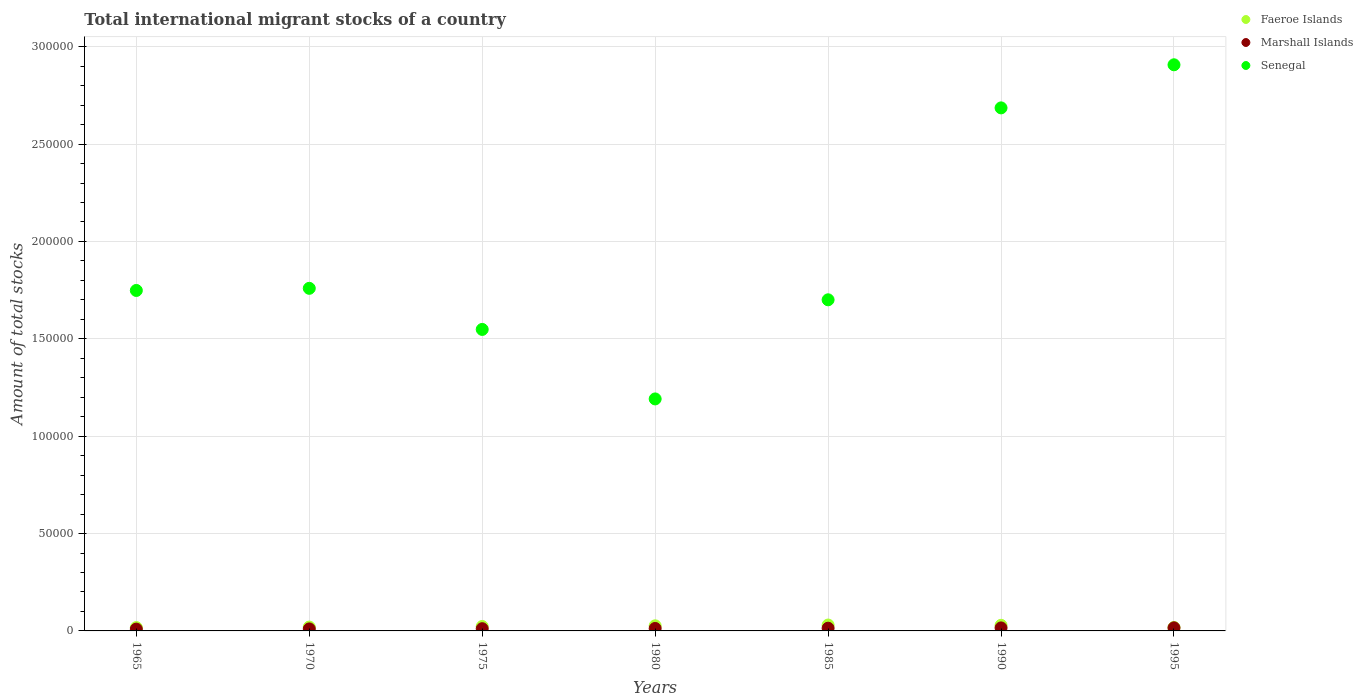How many different coloured dotlines are there?
Ensure brevity in your answer.  3. What is the amount of total stocks in in Senegal in 1980?
Your answer should be compact. 1.19e+05. Across all years, what is the maximum amount of total stocks in in Marshall Islands?
Your answer should be compact. 1586. Across all years, what is the minimum amount of total stocks in in Senegal?
Provide a succinct answer. 1.19e+05. In which year was the amount of total stocks in in Senegal minimum?
Your answer should be compact. 1980. What is the total amount of total stocks in in Faeroe Islands in the graph?
Your answer should be very brief. 1.63e+04. What is the difference between the amount of total stocks in in Marshall Islands in 1965 and that in 1985?
Offer a terse response. -463. What is the difference between the amount of total stocks in in Senegal in 1975 and the amount of total stocks in in Faeroe Islands in 1970?
Make the answer very short. 1.53e+05. What is the average amount of total stocks in in Marshall Islands per year?
Your response must be concise. 1273.14. In the year 1990, what is the difference between the amount of total stocks in in Faeroe Islands and amount of total stocks in in Senegal?
Ensure brevity in your answer.  -2.66e+05. In how many years, is the amount of total stocks in in Faeroe Islands greater than 130000?
Your response must be concise. 0. What is the ratio of the amount of total stocks in in Faeroe Islands in 1965 to that in 1970?
Ensure brevity in your answer.  0.87. What is the difference between the highest and the second highest amount of total stocks in in Senegal?
Provide a succinct answer. 2.21e+04. What is the difference between the highest and the lowest amount of total stocks in in Senegal?
Offer a very short reply. 1.72e+05. In how many years, is the amount of total stocks in in Marshall Islands greater than the average amount of total stocks in in Marshall Islands taken over all years?
Keep it short and to the point. 3. Is the sum of the amount of total stocks in in Senegal in 1990 and 1995 greater than the maximum amount of total stocks in in Faeroe Islands across all years?
Make the answer very short. Yes. Does the amount of total stocks in in Faeroe Islands monotonically increase over the years?
Give a very brief answer. No. Is the amount of total stocks in in Marshall Islands strictly less than the amount of total stocks in in Faeroe Islands over the years?
Provide a succinct answer. Yes. How many dotlines are there?
Give a very brief answer. 3. How many years are there in the graph?
Your answer should be very brief. 7. What is the difference between two consecutive major ticks on the Y-axis?
Provide a short and direct response. 5.00e+04. Does the graph contain any zero values?
Give a very brief answer. No. How many legend labels are there?
Give a very brief answer. 3. How are the legend labels stacked?
Offer a terse response. Vertical. What is the title of the graph?
Your answer should be compact. Total international migrant stocks of a country. What is the label or title of the Y-axis?
Ensure brevity in your answer.  Amount of total stocks. What is the Amount of total stocks of Faeroe Islands in 1965?
Make the answer very short. 1716. What is the Amount of total stocks of Marshall Islands in 1965?
Keep it short and to the point. 936. What is the Amount of total stocks of Senegal in 1965?
Provide a succinct answer. 1.75e+05. What is the Amount of total stocks in Faeroe Islands in 1970?
Your response must be concise. 1978. What is the Amount of total stocks in Marshall Islands in 1970?
Make the answer very short. 1035. What is the Amount of total stocks in Senegal in 1970?
Your answer should be very brief. 1.76e+05. What is the Amount of total stocks in Faeroe Islands in 1975?
Ensure brevity in your answer.  2280. What is the Amount of total stocks of Marshall Islands in 1975?
Your answer should be very brief. 1144. What is the Amount of total stocks in Senegal in 1975?
Keep it short and to the point. 1.55e+05. What is the Amount of total stocks in Faeroe Islands in 1980?
Provide a short and direct response. 2628. What is the Amount of total stocks in Marshall Islands in 1980?
Ensure brevity in your answer.  1265. What is the Amount of total stocks in Senegal in 1980?
Ensure brevity in your answer.  1.19e+05. What is the Amount of total stocks in Faeroe Islands in 1985?
Your answer should be compact. 3029. What is the Amount of total stocks in Marshall Islands in 1985?
Your answer should be very brief. 1399. What is the Amount of total stocks of Senegal in 1985?
Keep it short and to the point. 1.70e+05. What is the Amount of total stocks of Faeroe Islands in 1990?
Give a very brief answer. 2881. What is the Amount of total stocks in Marshall Islands in 1990?
Provide a short and direct response. 1547. What is the Amount of total stocks in Senegal in 1990?
Your answer should be compact. 2.69e+05. What is the Amount of total stocks in Faeroe Islands in 1995?
Provide a succinct answer. 1747. What is the Amount of total stocks of Marshall Islands in 1995?
Offer a terse response. 1586. What is the Amount of total stocks in Senegal in 1995?
Make the answer very short. 2.91e+05. Across all years, what is the maximum Amount of total stocks of Faeroe Islands?
Give a very brief answer. 3029. Across all years, what is the maximum Amount of total stocks in Marshall Islands?
Make the answer very short. 1586. Across all years, what is the maximum Amount of total stocks in Senegal?
Make the answer very short. 2.91e+05. Across all years, what is the minimum Amount of total stocks of Faeroe Islands?
Ensure brevity in your answer.  1716. Across all years, what is the minimum Amount of total stocks of Marshall Islands?
Your answer should be very brief. 936. Across all years, what is the minimum Amount of total stocks in Senegal?
Keep it short and to the point. 1.19e+05. What is the total Amount of total stocks of Faeroe Islands in the graph?
Ensure brevity in your answer.  1.63e+04. What is the total Amount of total stocks in Marshall Islands in the graph?
Provide a short and direct response. 8912. What is the total Amount of total stocks of Senegal in the graph?
Make the answer very short. 1.35e+06. What is the difference between the Amount of total stocks in Faeroe Islands in 1965 and that in 1970?
Your answer should be compact. -262. What is the difference between the Amount of total stocks of Marshall Islands in 1965 and that in 1970?
Ensure brevity in your answer.  -99. What is the difference between the Amount of total stocks in Senegal in 1965 and that in 1970?
Offer a terse response. -1093. What is the difference between the Amount of total stocks in Faeroe Islands in 1965 and that in 1975?
Offer a terse response. -564. What is the difference between the Amount of total stocks of Marshall Islands in 1965 and that in 1975?
Keep it short and to the point. -208. What is the difference between the Amount of total stocks of Senegal in 1965 and that in 1975?
Make the answer very short. 2.00e+04. What is the difference between the Amount of total stocks of Faeroe Islands in 1965 and that in 1980?
Offer a terse response. -912. What is the difference between the Amount of total stocks in Marshall Islands in 1965 and that in 1980?
Provide a succinct answer. -329. What is the difference between the Amount of total stocks in Senegal in 1965 and that in 1980?
Offer a very short reply. 5.57e+04. What is the difference between the Amount of total stocks in Faeroe Islands in 1965 and that in 1985?
Offer a very short reply. -1313. What is the difference between the Amount of total stocks of Marshall Islands in 1965 and that in 1985?
Offer a very short reply. -463. What is the difference between the Amount of total stocks of Senegal in 1965 and that in 1985?
Make the answer very short. 4798. What is the difference between the Amount of total stocks of Faeroe Islands in 1965 and that in 1990?
Make the answer very short. -1165. What is the difference between the Amount of total stocks in Marshall Islands in 1965 and that in 1990?
Make the answer very short. -611. What is the difference between the Amount of total stocks of Senegal in 1965 and that in 1990?
Your answer should be very brief. -9.38e+04. What is the difference between the Amount of total stocks in Faeroe Islands in 1965 and that in 1995?
Make the answer very short. -31. What is the difference between the Amount of total stocks in Marshall Islands in 1965 and that in 1995?
Offer a terse response. -650. What is the difference between the Amount of total stocks of Senegal in 1965 and that in 1995?
Your response must be concise. -1.16e+05. What is the difference between the Amount of total stocks of Faeroe Islands in 1970 and that in 1975?
Your answer should be very brief. -302. What is the difference between the Amount of total stocks of Marshall Islands in 1970 and that in 1975?
Your response must be concise. -109. What is the difference between the Amount of total stocks in Senegal in 1970 and that in 1975?
Give a very brief answer. 2.11e+04. What is the difference between the Amount of total stocks of Faeroe Islands in 1970 and that in 1980?
Your response must be concise. -650. What is the difference between the Amount of total stocks in Marshall Islands in 1970 and that in 1980?
Make the answer very short. -230. What is the difference between the Amount of total stocks of Senegal in 1970 and that in 1980?
Your response must be concise. 5.68e+04. What is the difference between the Amount of total stocks in Faeroe Islands in 1970 and that in 1985?
Your answer should be very brief. -1051. What is the difference between the Amount of total stocks in Marshall Islands in 1970 and that in 1985?
Offer a very short reply. -364. What is the difference between the Amount of total stocks in Senegal in 1970 and that in 1985?
Ensure brevity in your answer.  5891. What is the difference between the Amount of total stocks of Faeroe Islands in 1970 and that in 1990?
Ensure brevity in your answer.  -903. What is the difference between the Amount of total stocks of Marshall Islands in 1970 and that in 1990?
Your response must be concise. -512. What is the difference between the Amount of total stocks in Senegal in 1970 and that in 1990?
Your response must be concise. -9.27e+04. What is the difference between the Amount of total stocks in Faeroe Islands in 1970 and that in 1995?
Offer a terse response. 231. What is the difference between the Amount of total stocks of Marshall Islands in 1970 and that in 1995?
Give a very brief answer. -551. What is the difference between the Amount of total stocks in Senegal in 1970 and that in 1995?
Offer a terse response. -1.15e+05. What is the difference between the Amount of total stocks of Faeroe Islands in 1975 and that in 1980?
Ensure brevity in your answer.  -348. What is the difference between the Amount of total stocks of Marshall Islands in 1975 and that in 1980?
Provide a succinct answer. -121. What is the difference between the Amount of total stocks in Senegal in 1975 and that in 1980?
Provide a short and direct response. 3.57e+04. What is the difference between the Amount of total stocks in Faeroe Islands in 1975 and that in 1985?
Your answer should be very brief. -749. What is the difference between the Amount of total stocks of Marshall Islands in 1975 and that in 1985?
Your response must be concise. -255. What is the difference between the Amount of total stocks in Senegal in 1975 and that in 1985?
Provide a succinct answer. -1.52e+04. What is the difference between the Amount of total stocks in Faeroe Islands in 1975 and that in 1990?
Keep it short and to the point. -601. What is the difference between the Amount of total stocks of Marshall Islands in 1975 and that in 1990?
Ensure brevity in your answer.  -403. What is the difference between the Amount of total stocks of Senegal in 1975 and that in 1990?
Keep it short and to the point. -1.14e+05. What is the difference between the Amount of total stocks in Faeroe Islands in 1975 and that in 1995?
Provide a short and direct response. 533. What is the difference between the Amount of total stocks in Marshall Islands in 1975 and that in 1995?
Your answer should be compact. -442. What is the difference between the Amount of total stocks in Senegal in 1975 and that in 1995?
Your response must be concise. -1.36e+05. What is the difference between the Amount of total stocks of Faeroe Islands in 1980 and that in 1985?
Keep it short and to the point. -401. What is the difference between the Amount of total stocks in Marshall Islands in 1980 and that in 1985?
Make the answer very short. -134. What is the difference between the Amount of total stocks in Senegal in 1980 and that in 1985?
Your response must be concise. -5.09e+04. What is the difference between the Amount of total stocks of Faeroe Islands in 1980 and that in 1990?
Make the answer very short. -253. What is the difference between the Amount of total stocks of Marshall Islands in 1980 and that in 1990?
Offer a terse response. -282. What is the difference between the Amount of total stocks in Senegal in 1980 and that in 1990?
Ensure brevity in your answer.  -1.49e+05. What is the difference between the Amount of total stocks in Faeroe Islands in 1980 and that in 1995?
Give a very brief answer. 881. What is the difference between the Amount of total stocks in Marshall Islands in 1980 and that in 1995?
Keep it short and to the point. -321. What is the difference between the Amount of total stocks of Senegal in 1980 and that in 1995?
Give a very brief answer. -1.72e+05. What is the difference between the Amount of total stocks of Faeroe Islands in 1985 and that in 1990?
Provide a short and direct response. 148. What is the difference between the Amount of total stocks in Marshall Islands in 1985 and that in 1990?
Make the answer very short. -148. What is the difference between the Amount of total stocks of Senegal in 1985 and that in 1990?
Give a very brief answer. -9.85e+04. What is the difference between the Amount of total stocks in Faeroe Islands in 1985 and that in 1995?
Provide a succinct answer. 1282. What is the difference between the Amount of total stocks in Marshall Islands in 1985 and that in 1995?
Provide a short and direct response. -187. What is the difference between the Amount of total stocks of Senegal in 1985 and that in 1995?
Provide a short and direct response. -1.21e+05. What is the difference between the Amount of total stocks in Faeroe Islands in 1990 and that in 1995?
Provide a short and direct response. 1134. What is the difference between the Amount of total stocks of Marshall Islands in 1990 and that in 1995?
Provide a succinct answer. -39. What is the difference between the Amount of total stocks of Senegal in 1990 and that in 1995?
Make the answer very short. -2.21e+04. What is the difference between the Amount of total stocks in Faeroe Islands in 1965 and the Amount of total stocks in Marshall Islands in 1970?
Offer a very short reply. 681. What is the difference between the Amount of total stocks of Faeroe Islands in 1965 and the Amount of total stocks of Senegal in 1970?
Offer a very short reply. -1.74e+05. What is the difference between the Amount of total stocks in Marshall Islands in 1965 and the Amount of total stocks in Senegal in 1970?
Ensure brevity in your answer.  -1.75e+05. What is the difference between the Amount of total stocks of Faeroe Islands in 1965 and the Amount of total stocks of Marshall Islands in 1975?
Provide a succinct answer. 572. What is the difference between the Amount of total stocks in Faeroe Islands in 1965 and the Amount of total stocks in Senegal in 1975?
Provide a succinct answer. -1.53e+05. What is the difference between the Amount of total stocks in Marshall Islands in 1965 and the Amount of total stocks in Senegal in 1975?
Provide a succinct answer. -1.54e+05. What is the difference between the Amount of total stocks in Faeroe Islands in 1965 and the Amount of total stocks in Marshall Islands in 1980?
Make the answer very short. 451. What is the difference between the Amount of total stocks of Faeroe Islands in 1965 and the Amount of total stocks of Senegal in 1980?
Your response must be concise. -1.17e+05. What is the difference between the Amount of total stocks of Marshall Islands in 1965 and the Amount of total stocks of Senegal in 1980?
Provide a short and direct response. -1.18e+05. What is the difference between the Amount of total stocks of Faeroe Islands in 1965 and the Amount of total stocks of Marshall Islands in 1985?
Provide a succinct answer. 317. What is the difference between the Amount of total stocks of Faeroe Islands in 1965 and the Amount of total stocks of Senegal in 1985?
Provide a succinct answer. -1.68e+05. What is the difference between the Amount of total stocks of Marshall Islands in 1965 and the Amount of total stocks of Senegal in 1985?
Offer a very short reply. -1.69e+05. What is the difference between the Amount of total stocks of Faeroe Islands in 1965 and the Amount of total stocks of Marshall Islands in 1990?
Keep it short and to the point. 169. What is the difference between the Amount of total stocks of Faeroe Islands in 1965 and the Amount of total stocks of Senegal in 1990?
Keep it short and to the point. -2.67e+05. What is the difference between the Amount of total stocks in Marshall Islands in 1965 and the Amount of total stocks in Senegal in 1990?
Offer a very short reply. -2.68e+05. What is the difference between the Amount of total stocks of Faeroe Islands in 1965 and the Amount of total stocks of Marshall Islands in 1995?
Keep it short and to the point. 130. What is the difference between the Amount of total stocks in Faeroe Islands in 1965 and the Amount of total stocks in Senegal in 1995?
Ensure brevity in your answer.  -2.89e+05. What is the difference between the Amount of total stocks in Marshall Islands in 1965 and the Amount of total stocks in Senegal in 1995?
Ensure brevity in your answer.  -2.90e+05. What is the difference between the Amount of total stocks in Faeroe Islands in 1970 and the Amount of total stocks in Marshall Islands in 1975?
Offer a very short reply. 834. What is the difference between the Amount of total stocks in Faeroe Islands in 1970 and the Amount of total stocks in Senegal in 1975?
Offer a terse response. -1.53e+05. What is the difference between the Amount of total stocks in Marshall Islands in 1970 and the Amount of total stocks in Senegal in 1975?
Provide a succinct answer. -1.54e+05. What is the difference between the Amount of total stocks in Faeroe Islands in 1970 and the Amount of total stocks in Marshall Islands in 1980?
Your response must be concise. 713. What is the difference between the Amount of total stocks of Faeroe Islands in 1970 and the Amount of total stocks of Senegal in 1980?
Offer a terse response. -1.17e+05. What is the difference between the Amount of total stocks in Marshall Islands in 1970 and the Amount of total stocks in Senegal in 1980?
Your answer should be very brief. -1.18e+05. What is the difference between the Amount of total stocks of Faeroe Islands in 1970 and the Amount of total stocks of Marshall Islands in 1985?
Ensure brevity in your answer.  579. What is the difference between the Amount of total stocks of Faeroe Islands in 1970 and the Amount of total stocks of Senegal in 1985?
Keep it short and to the point. -1.68e+05. What is the difference between the Amount of total stocks in Marshall Islands in 1970 and the Amount of total stocks in Senegal in 1985?
Offer a terse response. -1.69e+05. What is the difference between the Amount of total stocks of Faeroe Islands in 1970 and the Amount of total stocks of Marshall Islands in 1990?
Make the answer very short. 431. What is the difference between the Amount of total stocks of Faeroe Islands in 1970 and the Amount of total stocks of Senegal in 1990?
Give a very brief answer. -2.67e+05. What is the difference between the Amount of total stocks in Marshall Islands in 1970 and the Amount of total stocks in Senegal in 1990?
Your answer should be compact. -2.68e+05. What is the difference between the Amount of total stocks of Faeroe Islands in 1970 and the Amount of total stocks of Marshall Islands in 1995?
Your answer should be compact. 392. What is the difference between the Amount of total stocks of Faeroe Islands in 1970 and the Amount of total stocks of Senegal in 1995?
Give a very brief answer. -2.89e+05. What is the difference between the Amount of total stocks of Marshall Islands in 1970 and the Amount of total stocks of Senegal in 1995?
Keep it short and to the point. -2.90e+05. What is the difference between the Amount of total stocks of Faeroe Islands in 1975 and the Amount of total stocks of Marshall Islands in 1980?
Ensure brevity in your answer.  1015. What is the difference between the Amount of total stocks in Faeroe Islands in 1975 and the Amount of total stocks in Senegal in 1980?
Ensure brevity in your answer.  -1.17e+05. What is the difference between the Amount of total stocks in Marshall Islands in 1975 and the Amount of total stocks in Senegal in 1980?
Keep it short and to the point. -1.18e+05. What is the difference between the Amount of total stocks in Faeroe Islands in 1975 and the Amount of total stocks in Marshall Islands in 1985?
Offer a terse response. 881. What is the difference between the Amount of total stocks in Faeroe Islands in 1975 and the Amount of total stocks in Senegal in 1985?
Provide a short and direct response. -1.68e+05. What is the difference between the Amount of total stocks in Marshall Islands in 1975 and the Amount of total stocks in Senegal in 1985?
Keep it short and to the point. -1.69e+05. What is the difference between the Amount of total stocks in Faeroe Islands in 1975 and the Amount of total stocks in Marshall Islands in 1990?
Provide a short and direct response. 733. What is the difference between the Amount of total stocks in Faeroe Islands in 1975 and the Amount of total stocks in Senegal in 1990?
Provide a succinct answer. -2.66e+05. What is the difference between the Amount of total stocks in Marshall Islands in 1975 and the Amount of total stocks in Senegal in 1990?
Your answer should be compact. -2.67e+05. What is the difference between the Amount of total stocks of Faeroe Islands in 1975 and the Amount of total stocks of Marshall Islands in 1995?
Keep it short and to the point. 694. What is the difference between the Amount of total stocks of Faeroe Islands in 1975 and the Amount of total stocks of Senegal in 1995?
Give a very brief answer. -2.88e+05. What is the difference between the Amount of total stocks in Marshall Islands in 1975 and the Amount of total stocks in Senegal in 1995?
Your answer should be compact. -2.90e+05. What is the difference between the Amount of total stocks in Faeroe Islands in 1980 and the Amount of total stocks in Marshall Islands in 1985?
Give a very brief answer. 1229. What is the difference between the Amount of total stocks of Faeroe Islands in 1980 and the Amount of total stocks of Senegal in 1985?
Offer a very short reply. -1.67e+05. What is the difference between the Amount of total stocks in Marshall Islands in 1980 and the Amount of total stocks in Senegal in 1985?
Provide a succinct answer. -1.69e+05. What is the difference between the Amount of total stocks of Faeroe Islands in 1980 and the Amount of total stocks of Marshall Islands in 1990?
Provide a succinct answer. 1081. What is the difference between the Amount of total stocks of Faeroe Islands in 1980 and the Amount of total stocks of Senegal in 1990?
Provide a succinct answer. -2.66e+05. What is the difference between the Amount of total stocks of Marshall Islands in 1980 and the Amount of total stocks of Senegal in 1990?
Your answer should be very brief. -2.67e+05. What is the difference between the Amount of total stocks in Faeroe Islands in 1980 and the Amount of total stocks in Marshall Islands in 1995?
Your answer should be very brief. 1042. What is the difference between the Amount of total stocks in Faeroe Islands in 1980 and the Amount of total stocks in Senegal in 1995?
Offer a terse response. -2.88e+05. What is the difference between the Amount of total stocks in Marshall Islands in 1980 and the Amount of total stocks in Senegal in 1995?
Give a very brief answer. -2.89e+05. What is the difference between the Amount of total stocks of Faeroe Islands in 1985 and the Amount of total stocks of Marshall Islands in 1990?
Your response must be concise. 1482. What is the difference between the Amount of total stocks of Faeroe Islands in 1985 and the Amount of total stocks of Senegal in 1990?
Offer a terse response. -2.66e+05. What is the difference between the Amount of total stocks of Marshall Islands in 1985 and the Amount of total stocks of Senegal in 1990?
Your response must be concise. -2.67e+05. What is the difference between the Amount of total stocks in Faeroe Islands in 1985 and the Amount of total stocks in Marshall Islands in 1995?
Provide a short and direct response. 1443. What is the difference between the Amount of total stocks in Faeroe Islands in 1985 and the Amount of total stocks in Senegal in 1995?
Give a very brief answer. -2.88e+05. What is the difference between the Amount of total stocks in Marshall Islands in 1985 and the Amount of total stocks in Senegal in 1995?
Offer a very short reply. -2.89e+05. What is the difference between the Amount of total stocks in Faeroe Islands in 1990 and the Amount of total stocks in Marshall Islands in 1995?
Your response must be concise. 1295. What is the difference between the Amount of total stocks in Faeroe Islands in 1990 and the Amount of total stocks in Senegal in 1995?
Make the answer very short. -2.88e+05. What is the difference between the Amount of total stocks in Marshall Islands in 1990 and the Amount of total stocks in Senegal in 1995?
Give a very brief answer. -2.89e+05. What is the average Amount of total stocks in Faeroe Islands per year?
Keep it short and to the point. 2322.71. What is the average Amount of total stocks in Marshall Islands per year?
Keep it short and to the point. 1273.14. What is the average Amount of total stocks in Senegal per year?
Offer a terse response. 1.93e+05. In the year 1965, what is the difference between the Amount of total stocks of Faeroe Islands and Amount of total stocks of Marshall Islands?
Your answer should be compact. 780. In the year 1965, what is the difference between the Amount of total stocks in Faeroe Islands and Amount of total stocks in Senegal?
Provide a short and direct response. -1.73e+05. In the year 1965, what is the difference between the Amount of total stocks of Marshall Islands and Amount of total stocks of Senegal?
Offer a terse response. -1.74e+05. In the year 1970, what is the difference between the Amount of total stocks of Faeroe Islands and Amount of total stocks of Marshall Islands?
Your answer should be compact. 943. In the year 1970, what is the difference between the Amount of total stocks in Faeroe Islands and Amount of total stocks in Senegal?
Give a very brief answer. -1.74e+05. In the year 1970, what is the difference between the Amount of total stocks in Marshall Islands and Amount of total stocks in Senegal?
Your answer should be compact. -1.75e+05. In the year 1975, what is the difference between the Amount of total stocks of Faeroe Islands and Amount of total stocks of Marshall Islands?
Provide a succinct answer. 1136. In the year 1975, what is the difference between the Amount of total stocks of Faeroe Islands and Amount of total stocks of Senegal?
Offer a very short reply. -1.53e+05. In the year 1975, what is the difference between the Amount of total stocks of Marshall Islands and Amount of total stocks of Senegal?
Offer a very short reply. -1.54e+05. In the year 1980, what is the difference between the Amount of total stocks of Faeroe Islands and Amount of total stocks of Marshall Islands?
Your answer should be very brief. 1363. In the year 1980, what is the difference between the Amount of total stocks of Faeroe Islands and Amount of total stocks of Senegal?
Your answer should be very brief. -1.16e+05. In the year 1980, what is the difference between the Amount of total stocks in Marshall Islands and Amount of total stocks in Senegal?
Make the answer very short. -1.18e+05. In the year 1985, what is the difference between the Amount of total stocks of Faeroe Islands and Amount of total stocks of Marshall Islands?
Your answer should be very brief. 1630. In the year 1985, what is the difference between the Amount of total stocks in Faeroe Islands and Amount of total stocks in Senegal?
Your response must be concise. -1.67e+05. In the year 1985, what is the difference between the Amount of total stocks in Marshall Islands and Amount of total stocks in Senegal?
Offer a terse response. -1.69e+05. In the year 1990, what is the difference between the Amount of total stocks of Faeroe Islands and Amount of total stocks of Marshall Islands?
Your response must be concise. 1334. In the year 1990, what is the difference between the Amount of total stocks in Faeroe Islands and Amount of total stocks in Senegal?
Provide a succinct answer. -2.66e+05. In the year 1990, what is the difference between the Amount of total stocks in Marshall Islands and Amount of total stocks in Senegal?
Your answer should be very brief. -2.67e+05. In the year 1995, what is the difference between the Amount of total stocks in Faeroe Islands and Amount of total stocks in Marshall Islands?
Make the answer very short. 161. In the year 1995, what is the difference between the Amount of total stocks in Faeroe Islands and Amount of total stocks in Senegal?
Keep it short and to the point. -2.89e+05. In the year 1995, what is the difference between the Amount of total stocks of Marshall Islands and Amount of total stocks of Senegal?
Give a very brief answer. -2.89e+05. What is the ratio of the Amount of total stocks in Faeroe Islands in 1965 to that in 1970?
Give a very brief answer. 0.87. What is the ratio of the Amount of total stocks in Marshall Islands in 1965 to that in 1970?
Give a very brief answer. 0.9. What is the ratio of the Amount of total stocks in Faeroe Islands in 1965 to that in 1975?
Offer a very short reply. 0.75. What is the ratio of the Amount of total stocks of Marshall Islands in 1965 to that in 1975?
Offer a terse response. 0.82. What is the ratio of the Amount of total stocks of Senegal in 1965 to that in 1975?
Offer a very short reply. 1.13. What is the ratio of the Amount of total stocks in Faeroe Islands in 1965 to that in 1980?
Keep it short and to the point. 0.65. What is the ratio of the Amount of total stocks in Marshall Islands in 1965 to that in 1980?
Provide a short and direct response. 0.74. What is the ratio of the Amount of total stocks in Senegal in 1965 to that in 1980?
Provide a short and direct response. 1.47. What is the ratio of the Amount of total stocks in Faeroe Islands in 1965 to that in 1985?
Your answer should be very brief. 0.57. What is the ratio of the Amount of total stocks in Marshall Islands in 1965 to that in 1985?
Your answer should be very brief. 0.67. What is the ratio of the Amount of total stocks in Senegal in 1965 to that in 1985?
Ensure brevity in your answer.  1.03. What is the ratio of the Amount of total stocks in Faeroe Islands in 1965 to that in 1990?
Your response must be concise. 0.6. What is the ratio of the Amount of total stocks in Marshall Islands in 1965 to that in 1990?
Your response must be concise. 0.6. What is the ratio of the Amount of total stocks of Senegal in 1965 to that in 1990?
Provide a short and direct response. 0.65. What is the ratio of the Amount of total stocks of Faeroe Islands in 1965 to that in 1995?
Offer a very short reply. 0.98. What is the ratio of the Amount of total stocks in Marshall Islands in 1965 to that in 1995?
Give a very brief answer. 0.59. What is the ratio of the Amount of total stocks of Senegal in 1965 to that in 1995?
Ensure brevity in your answer.  0.6. What is the ratio of the Amount of total stocks in Faeroe Islands in 1970 to that in 1975?
Offer a very short reply. 0.87. What is the ratio of the Amount of total stocks in Marshall Islands in 1970 to that in 1975?
Ensure brevity in your answer.  0.9. What is the ratio of the Amount of total stocks in Senegal in 1970 to that in 1975?
Ensure brevity in your answer.  1.14. What is the ratio of the Amount of total stocks of Faeroe Islands in 1970 to that in 1980?
Offer a terse response. 0.75. What is the ratio of the Amount of total stocks in Marshall Islands in 1970 to that in 1980?
Give a very brief answer. 0.82. What is the ratio of the Amount of total stocks of Senegal in 1970 to that in 1980?
Ensure brevity in your answer.  1.48. What is the ratio of the Amount of total stocks in Faeroe Islands in 1970 to that in 1985?
Your answer should be very brief. 0.65. What is the ratio of the Amount of total stocks in Marshall Islands in 1970 to that in 1985?
Offer a very short reply. 0.74. What is the ratio of the Amount of total stocks in Senegal in 1970 to that in 1985?
Your answer should be very brief. 1.03. What is the ratio of the Amount of total stocks of Faeroe Islands in 1970 to that in 1990?
Provide a short and direct response. 0.69. What is the ratio of the Amount of total stocks of Marshall Islands in 1970 to that in 1990?
Offer a terse response. 0.67. What is the ratio of the Amount of total stocks in Senegal in 1970 to that in 1990?
Your answer should be compact. 0.66. What is the ratio of the Amount of total stocks of Faeroe Islands in 1970 to that in 1995?
Make the answer very short. 1.13. What is the ratio of the Amount of total stocks of Marshall Islands in 1970 to that in 1995?
Your answer should be very brief. 0.65. What is the ratio of the Amount of total stocks in Senegal in 1970 to that in 1995?
Ensure brevity in your answer.  0.61. What is the ratio of the Amount of total stocks in Faeroe Islands in 1975 to that in 1980?
Your response must be concise. 0.87. What is the ratio of the Amount of total stocks in Marshall Islands in 1975 to that in 1980?
Your answer should be compact. 0.9. What is the ratio of the Amount of total stocks in Senegal in 1975 to that in 1980?
Your answer should be compact. 1.3. What is the ratio of the Amount of total stocks in Faeroe Islands in 1975 to that in 1985?
Make the answer very short. 0.75. What is the ratio of the Amount of total stocks of Marshall Islands in 1975 to that in 1985?
Your answer should be compact. 0.82. What is the ratio of the Amount of total stocks of Senegal in 1975 to that in 1985?
Ensure brevity in your answer.  0.91. What is the ratio of the Amount of total stocks in Faeroe Islands in 1975 to that in 1990?
Keep it short and to the point. 0.79. What is the ratio of the Amount of total stocks of Marshall Islands in 1975 to that in 1990?
Offer a terse response. 0.74. What is the ratio of the Amount of total stocks of Senegal in 1975 to that in 1990?
Your answer should be very brief. 0.58. What is the ratio of the Amount of total stocks of Faeroe Islands in 1975 to that in 1995?
Your answer should be compact. 1.31. What is the ratio of the Amount of total stocks in Marshall Islands in 1975 to that in 1995?
Make the answer very short. 0.72. What is the ratio of the Amount of total stocks in Senegal in 1975 to that in 1995?
Keep it short and to the point. 0.53. What is the ratio of the Amount of total stocks of Faeroe Islands in 1980 to that in 1985?
Ensure brevity in your answer.  0.87. What is the ratio of the Amount of total stocks in Marshall Islands in 1980 to that in 1985?
Provide a succinct answer. 0.9. What is the ratio of the Amount of total stocks in Senegal in 1980 to that in 1985?
Your answer should be very brief. 0.7. What is the ratio of the Amount of total stocks in Faeroe Islands in 1980 to that in 1990?
Your response must be concise. 0.91. What is the ratio of the Amount of total stocks in Marshall Islands in 1980 to that in 1990?
Your response must be concise. 0.82. What is the ratio of the Amount of total stocks in Senegal in 1980 to that in 1990?
Offer a very short reply. 0.44. What is the ratio of the Amount of total stocks of Faeroe Islands in 1980 to that in 1995?
Give a very brief answer. 1.5. What is the ratio of the Amount of total stocks in Marshall Islands in 1980 to that in 1995?
Your answer should be very brief. 0.8. What is the ratio of the Amount of total stocks in Senegal in 1980 to that in 1995?
Make the answer very short. 0.41. What is the ratio of the Amount of total stocks in Faeroe Islands in 1985 to that in 1990?
Your answer should be compact. 1.05. What is the ratio of the Amount of total stocks in Marshall Islands in 1985 to that in 1990?
Give a very brief answer. 0.9. What is the ratio of the Amount of total stocks in Senegal in 1985 to that in 1990?
Offer a terse response. 0.63. What is the ratio of the Amount of total stocks of Faeroe Islands in 1985 to that in 1995?
Ensure brevity in your answer.  1.73. What is the ratio of the Amount of total stocks of Marshall Islands in 1985 to that in 1995?
Offer a very short reply. 0.88. What is the ratio of the Amount of total stocks of Senegal in 1985 to that in 1995?
Provide a short and direct response. 0.58. What is the ratio of the Amount of total stocks of Faeroe Islands in 1990 to that in 1995?
Your answer should be compact. 1.65. What is the ratio of the Amount of total stocks in Marshall Islands in 1990 to that in 1995?
Offer a very short reply. 0.98. What is the ratio of the Amount of total stocks in Senegal in 1990 to that in 1995?
Make the answer very short. 0.92. What is the difference between the highest and the second highest Amount of total stocks of Faeroe Islands?
Give a very brief answer. 148. What is the difference between the highest and the second highest Amount of total stocks in Marshall Islands?
Offer a very short reply. 39. What is the difference between the highest and the second highest Amount of total stocks in Senegal?
Make the answer very short. 2.21e+04. What is the difference between the highest and the lowest Amount of total stocks in Faeroe Islands?
Your answer should be very brief. 1313. What is the difference between the highest and the lowest Amount of total stocks of Marshall Islands?
Make the answer very short. 650. What is the difference between the highest and the lowest Amount of total stocks of Senegal?
Keep it short and to the point. 1.72e+05. 